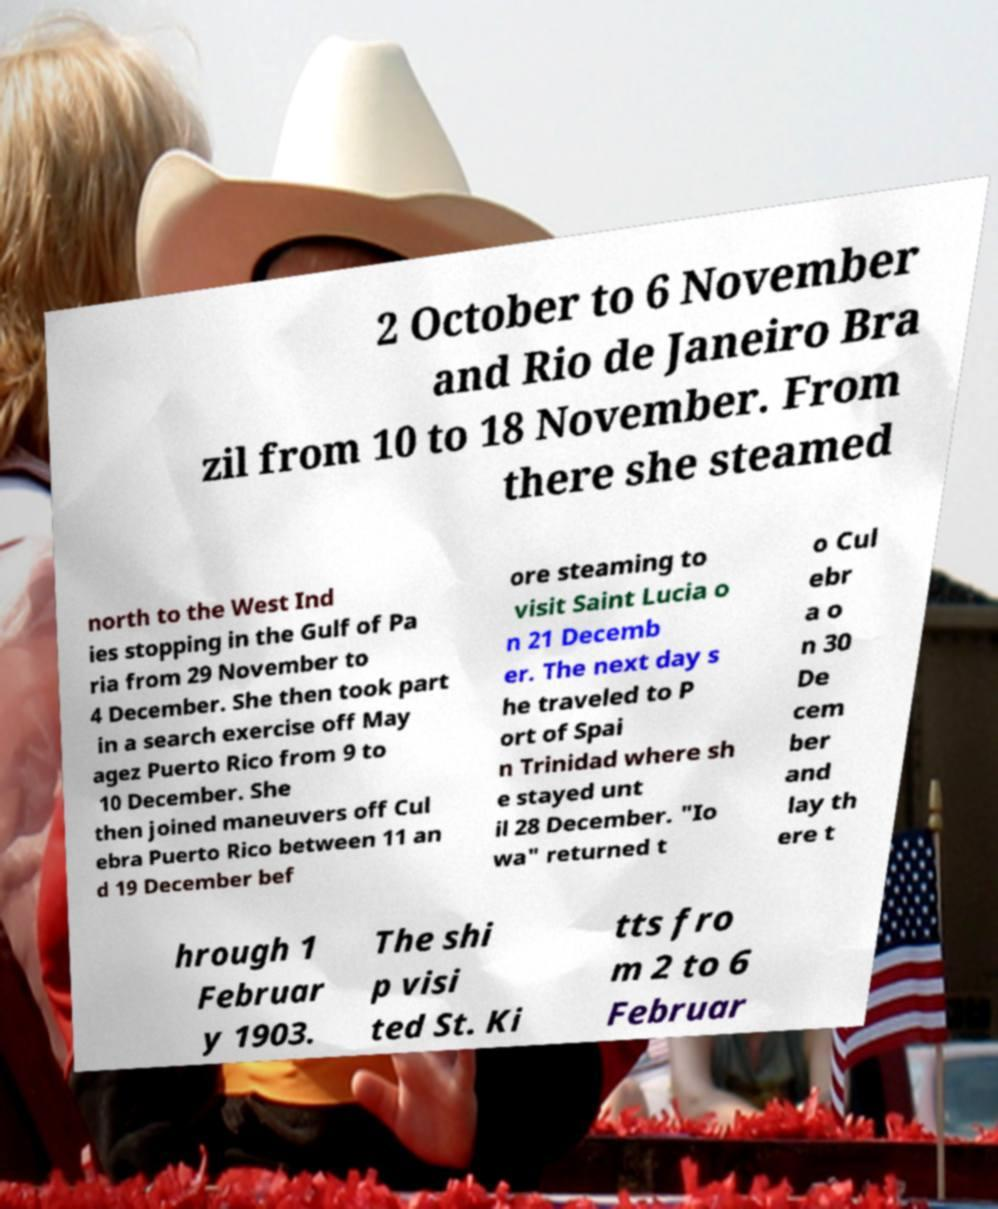Please read and relay the text visible in this image. What does it say? 2 October to 6 November and Rio de Janeiro Bra zil from 10 to 18 November. From there she steamed north to the West Ind ies stopping in the Gulf of Pa ria from 29 November to 4 December. She then took part in a search exercise off May agez Puerto Rico from 9 to 10 December. She then joined maneuvers off Cul ebra Puerto Rico between 11 an d 19 December bef ore steaming to visit Saint Lucia o n 21 Decemb er. The next day s he traveled to P ort of Spai n Trinidad where sh e stayed unt il 28 December. "Io wa" returned t o Cul ebr a o n 30 De cem ber and lay th ere t hrough 1 Februar y 1903. The shi p visi ted St. Ki tts fro m 2 to 6 Februar 